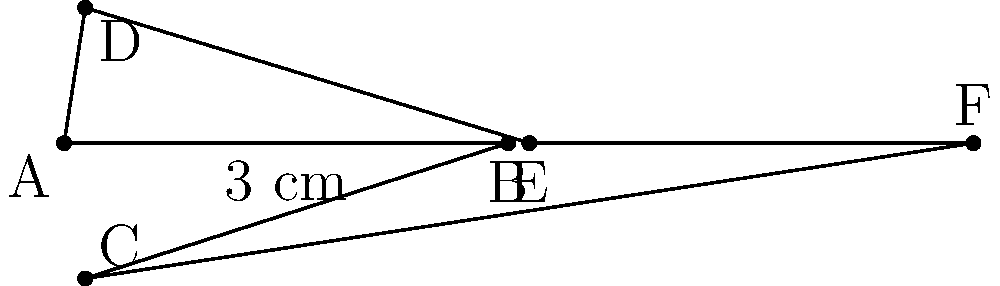Your carpenter friend has crafted a beautiful hexagonal wooden coaster for you to use in your pottery studio. If each side of the hexagon measures 3 cm, what is the perimeter of the coaster? To find the perimeter of a regular hexagon, we need to follow these steps:

1) Recall that a perimeter is the sum of all sides of a shape.

2) In a regular hexagon, all sides are equal in length.

3) We are given that each side of the hexagon is 3 cm long.

4) A hexagon has 6 sides.

5) To calculate the perimeter, we multiply the length of one side by the number of sides:

   Perimeter $= 6 \times \text{side length}$
   
   $= 6 \times 3$ cm
   
   $= 18$ cm

Therefore, the perimeter of the hexagonal wooden coaster is 18 cm.
Answer: $18$ cm 